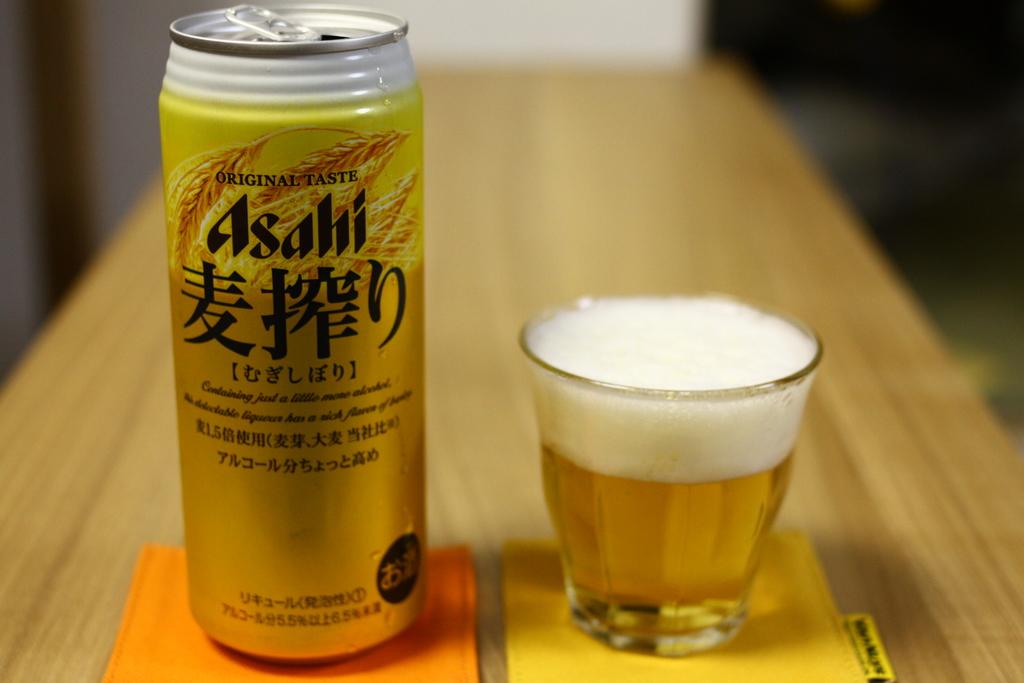What type of beer is it?
Offer a terse response. Asahi. 